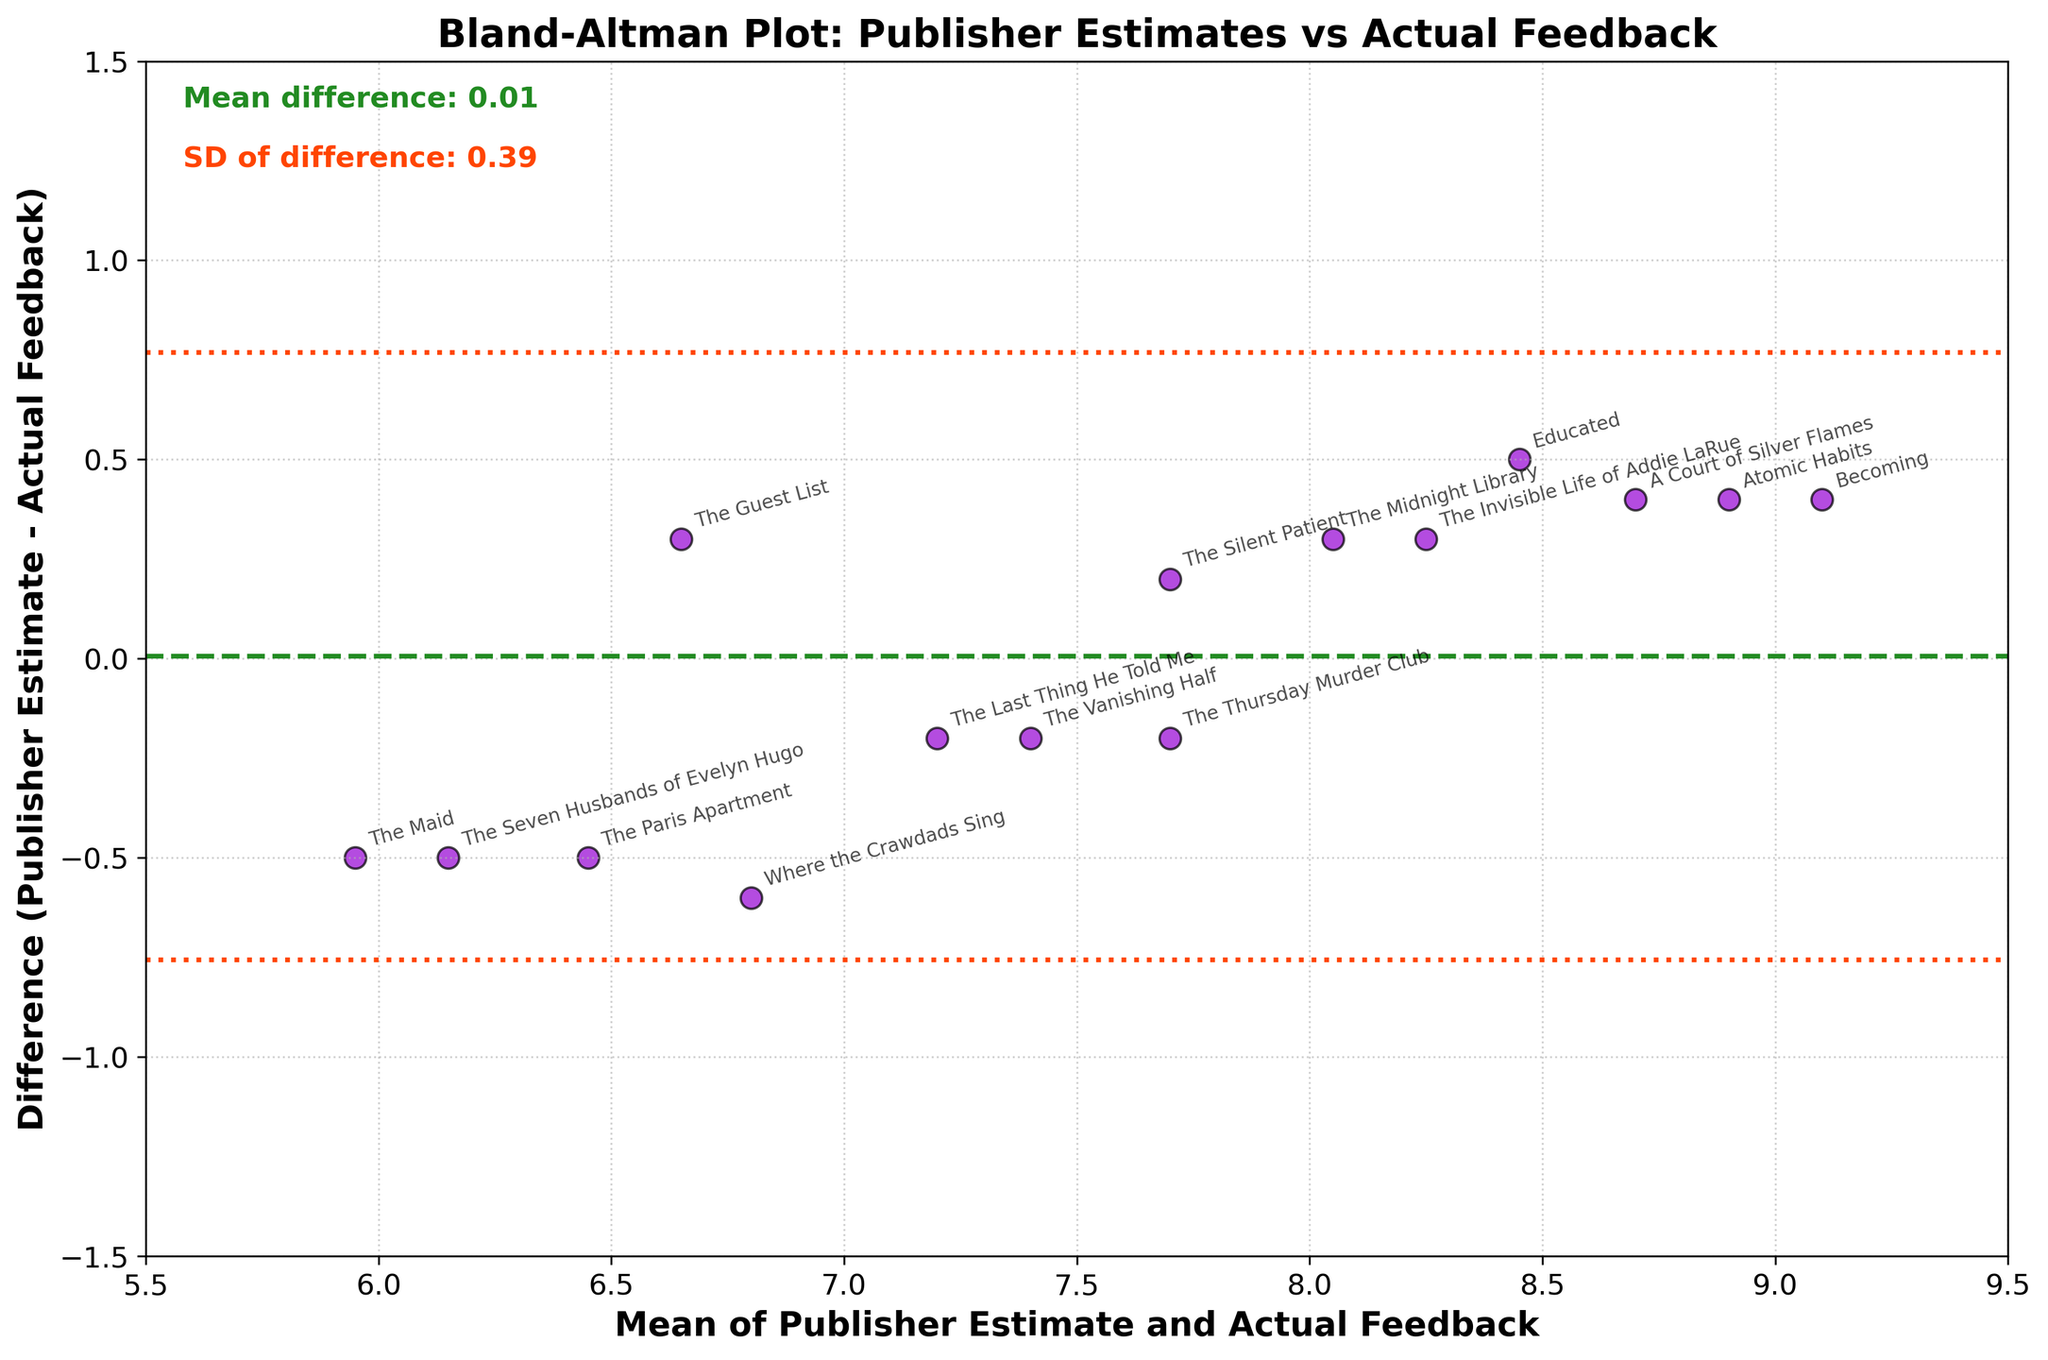What is the title of the plot? The title of the plot is displayed at the top of the figure. It reads "Bland-Altman Plot: Publisher Estimates vs Actual Feedback."
Answer: Bland-Altman Plot: Publisher Estimates vs Actual Feedback How many books were analyzed in this plot? By counting the number of data points (dots) on the figure or by counting the annotations corresponding to each book, you can determine the number of books analyzed.
Answer: 15 What do the green and red lines represent in the plot? The green dashed line represents the mean difference between publisher estimates and actual feedback. The red dotted lines represent the limits of agreement, which are ±1.96 times the standard deviation from the mean difference.
Answer: Mean difference and limits of agreement What is the mean difference between publisher estimates and actual feedback? The mean difference is the average of all the differences between publisher estimates and actual feedback. It is indicated by the green dashed line and is also textually provided in the top left corner of the plot.
Answer: 0.32 Which book has the largest positive difference between the publisher estimate and actual feedback? By looking at the position of the dots relative to the mean difference line, we find which dot is furthest above the green dashed line. The annotations help to identify the corresponding book.
Answer: The Guest List What is the range of mean values observed in the plot? The range of the x-axis, labeled as "Mean of Publisher Estimate and Actual Feedback," gives the range of the mean values observed in the plot. The limits of the x-axis can be checked to determine this.
Answer: 5.5 to 9.5 How many books have a mean value between 7 and 8? By identifying the data points that fall within the x-axis range of 7 to 8 and counting them, we can determine how many books have a mean value in this range.
Answer: 6 Which book's engagement prediction by the publisher was closest to actual reader feedback? The book closest to the mean difference (green dashed line) with the smallest absolute value of difference is the one whose prediction was closest to the actual reader feedback.
Answer: The Thursday Murder Club What is the value of the upper limit of agreement? The upper limit of agreement is the mean difference plus 1.96 times the standard deviation. This value is textually provided on the figure in the top left corner.
Answer: 1.32 Is there a general trend that can be observed from the differences in the plot? By observing the scatter of the data points around the mean difference, you can see if there is a pattern such as a systematic bias or if the differences are random and evenly distributed around the mean.
Answer: No general trend Which book has the largest negative difference between the publisher estimate and actual feedback? By looking at the position of the dots relative to the mean difference line, we find which dot is furthest below the green dashed line. The annotations help to identify the corresponding book.
Answer: Where the Crawdads Sing 